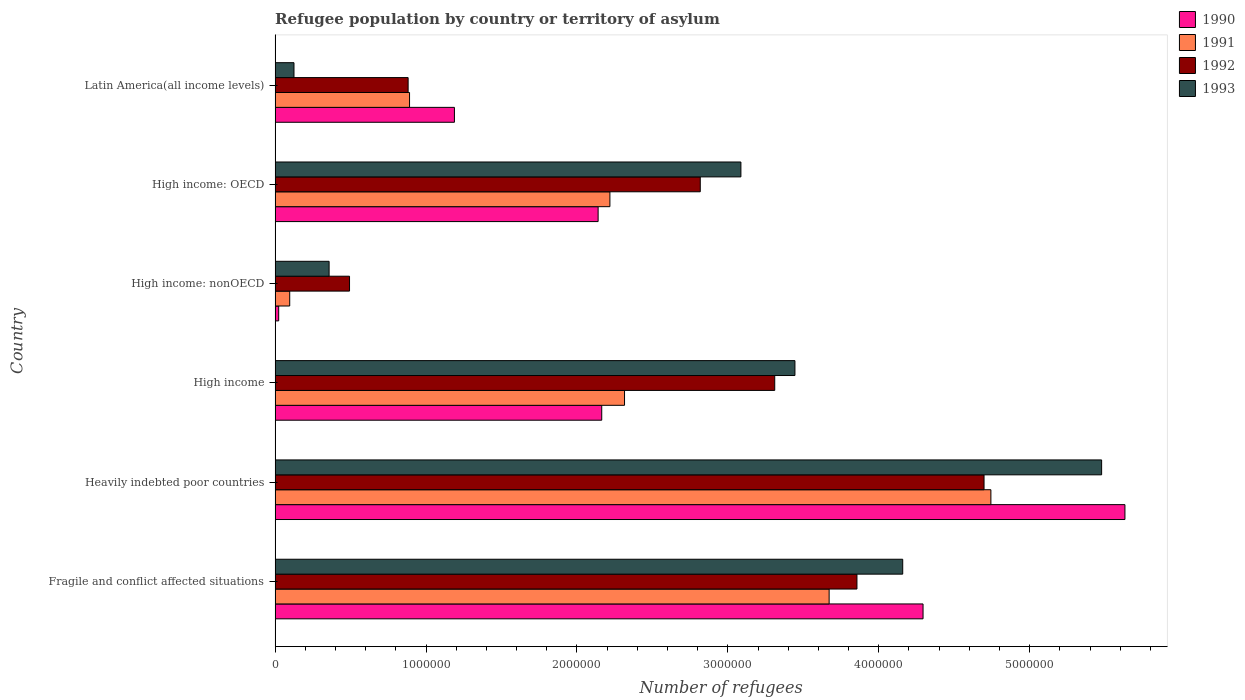How many groups of bars are there?
Provide a short and direct response. 6. Are the number of bars on each tick of the Y-axis equal?
Offer a terse response. Yes. How many bars are there on the 3rd tick from the top?
Your answer should be compact. 4. How many bars are there on the 2nd tick from the bottom?
Give a very brief answer. 4. What is the label of the 5th group of bars from the top?
Make the answer very short. Heavily indebted poor countries. In how many cases, is the number of bars for a given country not equal to the number of legend labels?
Provide a short and direct response. 0. What is the number of refugees in 1992 in High income?
Provide a succinct answer. 3.31e+06. Across all countries, what is the maximum number of refugees in 1993?
Keep it short and to the point. 5.48e+06. Across all countries, what is the minimum number of refugees in 1991?
Offer a very short reply. 9.69e+04. In which country was the number of refugees in 1993 maximum?
Provide a succinct answer. Heavily indebted poor countries. In which country was the number of refugees in 1990 minimum?
Your answer should be very brief. High income: nonOECD. What is the total number of refugees in 1993 in the graph?
Offer a very short reply. 1.66e+07. What is the difference between the number of refugees in 1992 in Heavily indebted poor countries and that in High income: OECD?
Keep it short and to the point. 1.88e+06. What is the difference between the number of refugees in 1990 in Heavily indebted poor countries and the number of refugees in 1991 in High income?
Offer a terse response. 3.32e+06. What is the average number of refugees in 1990 per country?
Give a very brief answer. 2.57e+06. What is the difference between the number of refugees in 1990 and number of refugees in 1991 in Heavily indebted poor countries?
Provide a succinct answer. 8.88e+05. What is the ratio of the number of refugees in 1993 in High income: OECD to that in Latin America(all income levels)?
Give a very brief answer. 24.64. Is the number of refugees in 1990 in High income: OECD less than that in Latin America(all income levels)?
Your response must be concise. No. What is the difference between the highest and the second highest number of refugees in 1991?
Ensure brevity in your answer.  1.07e+06. What is the difference between the highest and the lowest number of refugees in 1992?
Provide a succinct answer. 4.20e+06. Is it the case that in every country, the sum of the number of refugees in 1990 and number of refugees in 1993 is greater than the sum of number of refugees in 1991 and number of refugees in 1992?
Ensure brevity in your answer.  No. What does the 4th bar from the top in High income: nonOECD represents?
Ensure brevity in your answer.  1990. Are all the bars in the graph horizontal?
Make the answer very short. Yes. How many countries are there in the graph?
Provide a succinct answer. 6. What is the difference between two consecutive major ticks on the X-axis?
Make the answer very short. 1.00e+06. Are the values on the major ticks of X-axis written in scientific E-notation?
Ensure brevity in your answer.  No. Does the graph contain any zero values?
Ensure brevity in your answer.  No. Does the graph contain grids?
Your answer should be compact. No. How many legend labels are there?
Provide a succinct answer. 4. How are the legend labels stacked?
Offer a terse response. Vertical. What is the title of the graph?
Provide a short and direct response. Refugee population by country or territory of asylum. What is the label or title of the X-axis?
Ensure brevity in your answer.  Number of refugees. What is the Number of refugees in 1990 in Fragile and conflict affected situations?
Offer a very short reply. 4.29e+06. What is the Number of refugees in 1991 in Fragile and conflict affected situations?
Ensure brevity in your answer.  3.67e+06. What is the Number of refugees in 1992 in Fragile and conflict affected situations?
Provide a succinct answer. 3.86e+06. What is the Number of refugees of 1993 in Fragile and conflict affected situations?
Provide a succinct answer. 4.16e+06. What is the Number of refugees in 1990 in Heavily indebted poor countries?
Make the answer very short. 5.63e+06. What is the Number of refugees in 1991 in Heavily indebted poor countries?
Ensure brevity in your answer.  4.74e+06. What is the Number of refugees of 1992 in Heavily indebted poor countries?
Your answer should be very brief. 4.70e+06. What is the Number of refugees of 1993 in Heavily indebted poor countries?
Keep it short and to the point. 5.48e+06. What is the Number of refugees of 1990 in High income?
Give a very brief answer. 2.16e+06. What is the Number of refugees in 1991 in High income?
Ensure brevity in your answer.  2.32e+06. What is the Number of refugees in 1992 in High income?
Your response must be concise. 3.31e+06. What is the Number of refugees of 1993 in High income?
Provide a short and direct response. 3.44e+06. What is the Number of refugees of 1990 in High income: nonOECD?
Make the answer very short. 2.39e+04. What is the Number of refugees in 1991 in High income: nonOECD?
Make the answer very short. 9.69e+04. What is the Number of refugees of 1992 in High income: nonOECD?
Your answer should be very brief. 4.93e+05. What is the Number of refugees in 1993 in High income: nonOECD?
Your response must be concise. 3.58e+05. What is the Number of refugees in 1990 in High income: OECD?
Your answer should be very brief. 2.14e+06. What is the Number of refugees in 1991 in High income: OECD?
Keep it short and to the point. 2.22e+06. What is the Number of refugees of 1992 in High income: OECD?
Your answer should be very brief. 2.82e+06. What is the Number of refugees in 1993 in High income: OECD?
Offer a very short reply. 3.09e+06. What is the Number of refugees in 1990 in Latin America(all income levels)?
Offer a terse response. 1.19e+06. What is the Number of refugees of 1991 in Latin America(all income levels)?
Offer a terse response. 8.91e+05. What is the Number of refugees in 1992 in Latin America(all income levels)?
Provide a short and direct response. 8.82e+05. What is the Number of refugees of 1993 in Latin America(all income levels)?
Make the answer very short. 1.25e+05. Across all countries, what is the maximum Number of refugees in 1990?
Provide a short and direct response. 5.63e+06. Across all countries, what is the maximum Number of refugees in 1991?
Ensure brevity in your answer.  4.74e+06. Across all countries, what is the maximum Number of refugees in 1992?
Give a very brief answer. 4.70e+06. Across all countries, what is the maximum Number of refugees of 1993?
Keep it short and to the point. 5.48e+06. Across all countries, what is the minimum Number of refugees of 1990?
Offer a terse response. 2.39e+04. Across all countries, what is the minimum Number of refugees in 1991?
Make the answer very short. 9.69e+04. Across all countries, what is the minimum Number of refugees of 1992?
Keep it short and to the point. 4.93e+05. Across all countries, what is the minimum Number of refugees in 1993?
Keep it short and to the point. 1.25e+05. What is the total Number of refugees in 1990 in the graph?
Ensure brevity in your answer.  1.54e+07. What is the total Number of refugees in 1991 in the graph?
Ensure brevity in your answer.  1.39e+07. What is the total Number of refugees in 1992 in the graph?
Offer a very short reply. 1.61e+07. What is the total Number of refugees of 1993 in the graph?
Your answer should be compact. 1.66e+07. What is the difference between the Number of refugees in 1990 in Fragile and conflict affected situations and that in Heavily indebted poor countries?
Provide a succinct answer. -1.34e+06. What is the difference between the Number of refugees of 1991 in Fragile and conflict affected situations and that in Heavily indebted poor countries?
Keep it short and to the point. -1.07e+06. What is the difference between the Number of refugees in 1992 in Fragile and conflict affected situations and that in Heavily indebted poor countries?
Ensure brevity in your answer.  -8.42e+05. What is the difference between the Number of refugees in 1993 in Fragile and conflict affected situations and that in Heavily indebted poor countries?
Give a very brief answer. -1.32e+06. What is the difference between the Number of refugees in 1990 in Fragile and conflict affected situations and that in High income?
Provide a succinct answer. 2.13e+06. What is the difference between the Number of refugees of 1991 in Fragile and conflict affected situations and that in High income?
Your answer should be very brief. 1.36e+06. What is the difference between the Number of refugees in 1992 in Fragile and conflict affected situations and that in High income?
Provide a short and direct response. 5.45e+05. What is the difference between the Number of refugees of 1993 in Fragile and conflict affected situations and that in High income?
Offer a very short reply. 7.14e+05. What is the difference between the Number of refugees of 1990 in Fragile and conflict affected situations and that in High income: nonOECD?
Provide a short and direct response. 4.27e+06. What is the difference between the Number of refugees of 1991 in Fragile and conflict affected situations and that in High income: nonOECD?
Provide a short and direct response. 3.57e+06. What is the difference between the Number of refugees in 1992 in Fragile and conflict affected situations and that in High income: nonOECD?
Ensure brevity in your answer.  3.36e+06. What is the difference between the Number of refugees in 1993 in Fragile and conflict affected situations and that in High income: nonOECD?
Keep it short and to the point. 3.80e+06. What is the difference between the Number of refugees in 1990 in Fragile and conflict affected situations and that in High income: OECD?
Your answer should be compact. 2.15e+06. What is the difference between the Number of refugees in 1991 in Fragile and conflict affected situations and that in High income: OECD?
Your answer should be compact. 1.45e+06. What is the difference between the Number of refugees in 1992 in Fragile and conflict affected situations and that in High income: OECD?
Your answer should be compact. 1.04e+06. What is the difference between the Number of refugees in 1993 in Fragile and conflict affected situations and that in High income: OECD?
Ensure brevity in your answer.  1.07e+06. What is the difference between the Number of refugees in 1990 in Fragile and conflict affected situations and that in Latin America(all income levels)?
Keep it short and to the point. 3.10e+06. What is the difference between the Number of refugees of 1991 in Fragile and conflict affected situations and that in Latin America(all income levels)?
Offer a very short reply. 2.78e+06. What is the difference between the Number of refugees in 1992 in Fragile and conflict affected situations and that in Latin America(all income levels)?
Provide a succinct answer. 2.97e+06. What is the difference between the Number of refugees in 1993 in Fragile and conflict affected situations and that in Latin America(all income levels)?
Ensure brevity in your answer.  4.03e+06. What is the difference between the Number of refugees in 1990 in Heavily indebted poor countries and that in High income?
Ensure brevity in your answer.  3.47e+06. What is the difference between the Number of refugees of 1991 in Heavily indebted poor countries and that in High income?
Offer a terse response. 2.43e+06. What is the difference between the Number of refugees of 1992 in Heavily indebted poor countries and that in High income?
Offer a very short reply. 1.39e+06. What is the difference between the Number of refugees in 1993 in Heavily indebted poor countries and that in High income?
Your answer should be very brief. 2.03e+06. What is the difference between the Number of refugees in 1990 in Heavily indebted poor countries and that in High income: nonOECD?
Make the answer very short. 5.61e+06. What is the difference between the Number of refugees of 1991 in Heavily indebted poor countries and that in High income: nonOECD?
Your answer should be very brief. 4.65e+06. What is the difference between the Number of refugees of 1992 in Heavily indebted poor countries and that in High income: nonOECD?
Make the answer very short. 4.20e+06. What is the difference between the Number of refugees of 1993 in Heavily indebted poor countries and that in High income: nonOECD?
Offer a terse response. 5.12e+06. What is the difference between the Number of refugees of 1990 in Heavily indebted poor countries and that in High income: OECD?
Make the answer very short. 3.49e+06. What is the difference between the Number of refugees in 1991 in Heavily indebted poor countries and that in High income: OECD?
Your response must be concise. 2.52e+06. What is the difference between the Number of refugees of 1992 in Heavily indebted poor countries and that in High income: OECD?
Offer a terse response. 1.88e+06. What is the difference between the Number of refugees in 1993 in Heavily indebted poor countries and that in High income: OECD?
Offer a very short reply. 2.39e+06. What is the difference between the Number of refugees of 1990 in Heavily indebted poor countries and that in Latin America(all income levels)?
Make the answer very short. 4.44e+06. What is the difference between the Number of refugees of 1991 in Heavily indebted poor countries and that in Latin America(all income levels)?
Provide a short and direct response. 3.85e+06. What is the difference between the Number of refugees of 1992 in Heavily indebted poor countries and that in Latin America(all income levels)?
Make the answer very short. 3.82e+06. What is the difference between the Number of refugees of 1993 in Heavily indebted poor countries and that in Latin America(all income levels)?
Your response must be concise. 5.35e+06. What is the difference between the Number of refugees of 1990 in High income and that in High income: nonOECD?
Ensure brevity in your answer.  2.14e+06. What is the difference between the Number of refugees in 1991 in High income and that in High income: nonOECD?
Keep it short and to the point. 2.22e+06. What is the difference between the Number of refugees of 1992 in High income and that in High income: nonOECD?
Offer a very short reply. 2.82e+06. What is the difference between the Number of refugees of 1993 in High income and that in High income: nonOECD?
Your answer should be very brief. 3.09e+06. What is the difference between the Number of refugees in 1990 in High income and that in High income: OECD?
Make the answer very short. 2.39e+04. What is the difference between the Number of refugees of 1991 in High income and that in High income: OECD?
Ensure brevity in your answer.  9.69e+04. What is the difference between the Number of refugees of 1992 in High income and that in High income: OECD?
Your answer should be very brief. 4.93e+05. What is the difference between the Number of refugees in 1993 in High income and that in High income: OECD?
Keep it short and to the point. 3.58e+05. What is the difference between the Number of refugees of 1990 in High income and that in Latin America(all income levels)?
Offer a very short reply. 9.76e+05. What is the difference between the Number of refugees of 1991 in High income and that in Latin America(all income levels)?
Your answer should be very brief. 1.42e+06. What is the difference between the Number of refugees of 1992 in High income and that in Latin America(all income levels)?
Provide a succinct answer. 2.43e+06. What is the difference between the Number of refugees of 1993 in High income and that in Latin America(all income levels)?
Keep it short and to the point. 3.32e+06. What is the difference between the Number of refugees in 1990 in High income: nonOECD and that in High income: OECD?
Offer a very short reply. -2.12e+06. What is the difference between the Number of refugees of 1991 in High income: nonOECD and that in High income: OECD?
Offer a terse response. -2.12e+06. What is the difference between the Number of refugees in 1992 in High income: nonOECD and that in High income: OECD?
Make the answer very short. -2.32e+06. What is the difference between the Number of refugees in 1993 in High income: nonOECD and that in High income: OECD?
Offer a terse response. -2.73e+06. What is the difference between the Number of refugees in 1990 in High income: nonOECD and that in Latin America(all income levels)?
Offer a terse response. -1.16e+06. What is the difference between the Number of refugees in 1991 in High income: nonOECD and that in Latin America(all income levels)?
Provide a short and direct response. -7.94e+05. What is the difference between the Number of refugees in 1992 in High income: nonOECD and that in Latin America(all income levels)?
Provide a succinct answer. -3.88e+05. What is the difference between the Number of refugees of 1993 in High income: nonOECD and that in Latin America(all income levels)?
Your response must be concise. 2.33e+05. What is the difference between the Number of refugees of 1990 in High income: OECD and that in Latin America(all income levels)?
Your answer should be compact. 9.52e+05. What is the difference between the Number of refugees of 1991 in High income: OECD and that in Latin America(all income levels)?
Your answer should be compact. 1.33e+06. What is the difference between the Number of refugees of 1992 in High income: OECD and that in Latin America(all income levels)?
Offer a very short reply. 1.94e+06. What is the difference between the Number of refugees in 1993 in High income: OECD and that in Latin America(all income levels)?
Your response must be concise. 2.96e+06. What is the difference between the Number of refugees of 1990 in Fragile and conflict affected situations and the Number of refugees of 1991 in Heavily indebted poor countries?
Provide a succinct answer. -4.49e+05. What is the difference between the Number of refugees of 1990 in Fragile and conflict affected situations and the Number of refugees of 1992 in Heavily indebted poor countries?
Your answer should be compact. -4.04e+05. What is the difference between the Number of refugees in 1990 in Fragile and conflict affected situations and the Number of refugees in 1993 in Heavily indebted poor countries?
Make the answer very short. -1.18e+06. What is the difference between the Number of refugees in 1991 in Fragile and conflict affected situations and the Number of refugees in 1992 in Heavily indebted poor countries?
Your response must be concise. -1.03e+06. What is the difference between the Number of refugees in 1991 in Fragile and conflict affected situations and the Number of refugees in 1993 in Heavily indebted poor countries?
Your answer should be very brief. -1.81e+06. What is the difference between the Number of refugees in 1992 in Fragile and conflict affected situations and the Number of refugees in 1993 in Heavily indebted poor countries?
Keep it short and to the point. -1.62e+06. What is the difference between the Number of refugees of 1990 in Fragile and conflict affected situations and the Number of refugees of 1991 in High income?
Offer a terse response. 1.98e+06. What is the difference between the Number of refugees in 1990 in Fragile and conflict affected situations and the Number of refugees in 1992 in High income?
Provide a short and direct response. 9.83e+05. What is the difference between the Number of refugees of 1990 in Fragile and conflict affected situations and the Number of refugees of 1993 in High income?
Provide a succinct answer. 8.49e+05. What is the difference between the Number of refugees of 1991 in Fragile and conflict affected situations and the Number of refugees of 1992 in High income?
Provide a short and direct response. 3.60e+05. What is the difference between the Number of refugees of 1991 in Fragile and conflict affected situations and the Number of refugees of 1993 in High income?
Provide a succinct answer. 2.27e+05. What is the difference between the Number of refugees in 1992 in Fragile and conflict affected situations and the Number of refugees in 1993 in High income?
Your response must be concise. 4.11e+05. What is the difference between the Number of refugees in 1990 in Fragile and conflict affected situations and the Number of refugees in 1991 in High income: nonOECD?
Provide a succinct answer. 4.20e+06. What is the difference between the Number of refugees in 1990 in Fragile and conflict affected situations and the Number of refugees in 1992 in High income: nonOECD?
Your answer should be very brief. 3.80e+06. What is the difference between the Number of refugees in 1990 in Fragile and conflict affected situations and the Number of refugees in 1993 in High income: nonOECD?
Ensure brevity in your answer.  3.94e+06. What is the difference between the Number of refugees of 1991 in Fragile and conflict affected situations and the Number of refugees of 1992 in High income: nonOECD?
Your response must be concise. 3.18e+06. What is the difference between the Number of refugees of 1991 in Fragile and conflict affected situations and the Number of refugees of 1993 in High income: nonOECD?
Provide a succinct answer. 3.31e+06. What is the difference between the Number of refugees of 1992 in Fragile and conflict affected situations and the Number of refugees of 1993 in High income: nonOECD?
Your response must be concise. 3.50e+06. What is the difference between the Number of refugees in 1990 in Fragile and conflict affected situations and the Number of refugees in 1991 in High income: OECD?
Your response must be concise. 2.07e+06. What is the difference between the Number of refugees of 1990 in Fragile and conflict affected situations and the Number of refugees of 1992 in High income: OECD?
Offer a very short reply. 1.48e+06. What is the difference between the Number of refugees of 1990 in Fragile and conflict affected situations and the Number of refugees of 1993 in High income: OECD?
Provide a succinct answer. 1.21e+06. What is the difference between the Number of refugees in 1991 in Fragile and conflict affected situations and the Number of refugees in 1992 in High income: OECD?
Your response must be concise. 8.54e+05. What is the difference between the Number of refugees of 1991 in Fragile and conflict affected situations and the Number of refugees of 1993 in High income: OECD?
Provide a succinct answer. 5.85e+05. What is the difference between the Number of refugees in 1992 in Fragile and conflict affected situations and the Number of refugees in 1993 in High income: OECD?
Your answer should be compact. 7.69e+05. What is the difference between the Number of refugees in 1990 in Fragile and conflict affected situations and the Number of refugees in 1991 in Latin America(all income levels)?
Offer a very short reply. 3.40e+06. What is the difference between the Number of refugees in 1990 in Fragile and conflict affected situations and the Number of refugees in 1992 in Latin America(all income levels)?
Make the answer very short. 3.41e+06. What is the difference between the Number of refugees of 1990 in Fragile and conflict affected situations and the Number of refugees of 1993 in Latin America(all income levels)?
Offer a terse response. 4.17e+06. What is the difference between the Number of refugees of 1991 in Fragile and conflict affected situations and the Number of refugees of 1992 in Latin America(all income levels)?
Give a very brief answer. 2.79e+06. What is the difference between the Number of refugees in 1991 in Fragile and conflict affected situations and the Number of refugees in 1993 in Latin America(all income levels)?
Offer a terse response. 3.55e+06. What is the difference between the Number of refugees of 1992 in Fragile and conflict affected situations and the Number of refugees of 1993 in Latin America(all income levels)?
Your response must be concise. 3.73e+06. What is the difference between the Number of refugees in 1990 in Heavily indebted poor countries and the Number of refugees in 1991 in High income?
Make the answer very short. 3.32e+06. What is the difference between the Number of refugees in 1990 in Heavily indebted poor countries and the Number of refugees in 1992 in High income?
Ensure brevity in your answer.  2.32e+06. What is the difference between the Number of refugees in 1990 in Heavily indebted poor countries and the Number of refugees in 1993 in High income?
Offer a very short reply. 2.19e+06. What is the difference between the Number of refugees of 1991 in Heavily indebted poor countries and the Number of refugees of 1992 in High income?
Ensure brevity in your answer.  1.43e+06. What is the difference between the Number of refugees of 1991 in Heavily indebted poor countries and the Number of refugees of 1993 in High income?
Ensure brevity in your answer.  1.30e+06. What is the difference between the Number of refugees of 1992 in Heavily indebted poor countries and the Number of refugees of 1993 in High income?
Ensure brevity in your answer.  1.25e+06. What is the difference between the Number of refugees of 1990 in Heavily indebted poor countries and the Number of refugees of 1991 in High income: nonOECD?
Keep it short and to the point. 5.53e+06. What is the difference between the Number of refugees in 1990 in Heavily indebted poor countries and the Number of refugees in 1992 in High income: nonOECD?
Provide a succinct answer. 5.14e+06. What is the difference between the Number of refugees of 1990 in Heavily indebted poor countries and the Number of refugees of 1993 in High income: nonOECD?
Keep it short and to the point. 5.27e+06. What is the difference between the Number of refugees in 1991 in Heavily indebted poor countries and the Number of refugees in 1992 in High income: nonOECD?
Offer a very short reply. 4.25e+06. What is the difference between the Number of refugees of 1991 in Heavily indebted poor countries and the Number of refugees of 1993 in High income: nonOECD?
Your response must be concise. 4.38e+06. What is the difference between the Number of refugees in 1992 in Heavily indebted poor countries and the Number of refugees in 1993 in High income: nonOECD?
Offer a very short reply. 4.34e+06. What is the difference between the Number of refugees in 1990 in Heavily indebted poor countries and the Number of refugees in 1991 in High income: OECD?
Provide a short and direct response. 3.41e+06. What is the difference between the Number of refugees in 1990 in Heavily indebted poor countries and the Number of refugees in 1992 in High income: OECD?
Provide a short and direct response. 2.81e+06. What is the difference between the Number of refugees of 1990 in Heavily indebted poor countries and the Number of refugees of 1993 in High income: OECD?
Make the answer very short. 2.54e+06. What is the difference between the Number of refugees in 1991 in Heavily indebted poor countries and the Number of refugees in 1992 in High income: OECD?
Make the answer very short. 1.93e+06. What is the difference between the Number of refugees in 1991 in Heavily indebted poor countries and the Number of refugees in 1993 in High income: OECD?
Ensure brevity in your answer.  1.66e+06. What is the difference between the Number of refugees in 1992 in Heavily indebted poor countries and the Number of refugees in 1993 in High income: OECD?
Offer a terse response. 1.61e+06. What is the difference between the Number of refugees in 1990 in Heavily indebted poor countries and the Number of refugees in 1991 in Latin America(all income levels)?
Offer a very short reply. 4.74e+06. What is the difference between the Number of refugees of 1990 in Heavily indebted poor countries and the Number of refugees of 1992 in Latin America(all income levels)?
Ensure brevity in your answer.  4.75e+06. What is the difference between the Number of refugees of 1990 in Heavily indebted poor countries and the Number of refugees of 1993 in Latin America(all income levels)?
Make the answer very short. 5.51e+06. What is the difference between the Number of refugees in 1991 in Heavily indebted poor countries and the Number of refugees in 1992 in Latin America(all income levels)?
Your answer should be compact. 3.86e+06. What is the difference between the Number of refugees in 1991 in Heavily indebted poor countries and the Number of refugees in 1993 in Latin America(all income levels)?
Your answer should be very brief. 4.62e+06. What is the difference between the Number of refugees of 1992 in Heavily indebted poor countries and the Number of refugees of 1993 in Latin America(all income levels)?
Keep it short and to the point. 4.57e+06. What is the difference between the Number of refugees in 1990 in High income and the Number of refugees in 1991 in High income: nonOECD?
Ensure brevity in your answer.  2.07e+06. What is the difference between the Number of refugees of 1990 in High income and the Number of refugees of 1992 in High income: nonOECD?
Your response must be concise. 1.67e+06. What is the difference between the Number of refugees of 1990 in High income and the Number of refugees of 1993 in High income: nonOECD?
Provide a succinct answer. 1.81e+06. What is the difference between the Number of refugees of 1991 in High income and the Number of refugees of 1992 in High income: nonOECD?
Provide a succinct answer. 1.82e+06. What is the difference between the Number of refugees of 1991 in High income and the Number of refugees of 1993 in High income: nonOECD?
Your answer should be very brief. 1.96e+06. What is the difference between the Number of refugees of 1992 in High income and the Number of refugees of 1993 in High income: nonOECD?
Make the answer very short. 2.95e+06. What is the difference between the Number of refugees of 1990 in High income and the Number of refugees of 1991 in High income: OECD?
Provide a short and direct response. -5.41e+04. What is the difference between the Number of refugees in 1990 in High income and the Number of refugees in 1992 in High income: OECD?
Offer a terse response. -6.53e+05. What is the difference between the Number of refugees of 1990 in High income and the Number of refugees of 1993 in High income: OECD?
Your answer should be very brief. -9.22e+05. What is the difference between the Number of refugees of 1991 in High income and the Number of refugees of 1992 in High income: OECD?
Make the answer very short. -5.02e+05. What is the difference between the Number of refugees in 1991 in High income and the Number of refugees in 1993 in High income: OECD?
Offer a very short reply. -7.71e+05. What is the difference between the Number of refugees of 1992 in High income and the Number of refugees of 1993 in High income: OECD?
Provide a succinct answer. 2.24e+05. What is the difference between the Number of refugees of 1990 in High income and the Number of refugees of 1991 in Latin America(all income levels)?
Keep it short and to the point. 1.27e+06. What is the difference between the Number of refugees of 1990 in High income and the Number of refugees of 1992 in Latin America(all income levels)?
Keep it short and to the point. 1.28e+06. What is the difference between the Number of refugees in 1990 in High income and the Number of refugees in 1993 in Latin America(all income levels)?
Make the answer very short. 2.04e+06. What is the difference between the Number of refugees in 1991 in High income and the Number of refugees in 1992 in Latin America(all income levels)?
Provide a short and direct response. 1.43e+06. What is the difference between the Number of refugees in 1991 in High income and the Number of refugees in 1993 in Latin America(all income levels)?
Keep it short and to the point. 2.19e+06. What is the difference between the Number of refugees in 1992 in High income and the Number of refugees in 1993 in Latin America(all income levels)?
Provide a short and direct response. 3.19e+06. What is the difference between the Number of refugees of 1990 in High income: nonOECD and the Number of refugees of 1991 in High income: OECD?
Offer a terse response. -2.19e+06. What is the difference between the Number of refugees of 1990 in High income: nonOECD and the Number of refugees of 1992 in High income: OECD?
Ensure brevity in your answer.  -2.79e+06. What is the difference between the Number of refugees of 1990 in High income: nonOECD and the Number of refugees of 1993 in High income: OECD?
Offer a very short reply. -3.06e+06. What is the difference between the Number of refugees of 1991 in High income: nonOECD and the Number of refugees of 1992 in High income: OECD?
Ensure brevity in your answer.  -2.72e+06. What is the difference between the Number of refugees in 1991 in High income: nonOECD and the Number of refugees in 1993 in High income: OECD?
Provide a succinct answer. -2.99e+06. What is the difference between the Number of refugees in 1992 in High income: nonOECD and the Number of refugees in 1993 in High income: OECD?
Give a very brief answer. -2.59e+06. What is the difference between the Number of refugees of 1990 in High income: nonOECD and the Number of refugees of 1991 in Latin America(all income levels)?
Your answer should be compact. -8.67e+05. What is the difference between the Number of refugees of 1990 in High income: nonOECD and the Number of refugees of 1992 in Latin America(all income levels)?
Offer a terse response. -8.58e+05. What is the difference between the Number of refugees in 1990 in High income: nonOECD and the Number of refugees in 1993 in Latin America(all income levels)?
Provide a succinct answer. -1.01e+05. What is the difference between the Number of refugees in 1991 in High income: nonOECD and the Number of refugees in 1992 in Latin America(all income levels)?
Your answer should be very brief. -7.85e+05. What is the difference between the Number of refugees of 1991 in High income: nonOECD and the Number of refugees of 1993 in Latin America(all income levels)?
Provide a succinct answer. -2.83e+04. What is the difference between the Number of refugees in 1992 in High income: nonOECD and the Number of refugees in 1993 in Latin America(all income levels)?
Your answer should be very brief. 3.68e+05. What is the difference between the Number of refugees in 1990 in High income: OECD and the Number of refugees in 1991 in Latin America(all income levels)?
Offer a very short reply. 1.25e+06. What is the difference between the Number of refugees of 1990 in High income: OECD and the Number of refugees of 1992 in Latin America(all income levels)?
Make the answer very short. 1.26e+06. What is the difference between the Number of refugees in 1990 in High income: OECD and the Number of refugees in 1993 in Latin America(all income levels)?
Your answer should be compact. 2.02e+06. What is the difference between the Number of refugees of 1991 in High income: OECD and the Number of refugees of 1992 in Latin America(all income levels)?
Give a very brief answer. 1.34e+06. What is the difference between the Number of refugees of 1991 in High income: OECD and the Number of refugees of 1993 in Latin America(all income levels)?
Your answer should be compact. 2.09e+06. What is the difference between the Number of refugees of 1992 in High income: OECD and the Number of refugees of 1993 in Latin America(all income levels)?
Ensure brevity in your answer.  2.69e+06. What is the average Number of refugees of 1990 per country?
Provide a succinct answer. 2.57e+06. What is the average Number of refugees of 1991 per country?
Keep it short and to the point. 2.32e+06. What is the average Number of refugees in 1992 per country?
Keep it short and to the point. 2.68e+06. What is the average Number of refugees in 1993 per country?
Give a very brief answer. 2.77e+06. What is the difference between the Number of refugees in 1990 and Number of refugees in 1991 in Fragile and conflict affected situations?
Offer a very short reply. 6.22e+05. What is the difference between the Number of refugees of 1990 and Number of refugees of 1992 in Fragile and conflict affected situations?
Offer a very short reply. 4.38e+05. What is the difference between the Number of refugees in 1990 and Number of refugees in 1993 in Fragile and conflict affected situations?
Give a very brief answer. 1.35e+05. What is the difference between the Number of refugees in 1991 and Number of refugees in 1992 in Fragile and conflict affected situations?
Your answer should be very brief. -1.84e+05. What is the difference between the Number of refugees of 1991 and Number of refugees of 1993 in Fragile and conflict affected situations?
Your answer should be very brief. -4.88e+05. What is the difference between the Number of refugees in 1992 and Number of refugees in 1993 in Fragile and conflict affected situations?
Provide a short and direct response. -3.03e+05. What is the difference between the Number of refugees in 1990 and Number of refugees in 1991 in Heavily indebted poor countries?
Provide a succinct answer. 8.88e+05. What is the difference between the Number of refugees in 1990 and Number of refugees in 1992 in Heavily indebted poor countries?
Offer a very short reply. 9.34e+05. What is the difference between the Number of refugees in 1990 and Number of refugees in 1993 in Heavily indebted poor countries?
Provide a short and direct response. 1.54e+05. What is the difference between the Number of refugees of 1991 and Number of refugees of 1992 in Heavily indebted poor countries?
Your response must be concise. 4.54e+04. What is the difference between the Number of refugees of 1991 and Number of refugees of 1993 in Heavily indebted poor countries?
Your answer should be very brief. -7.34e+05. What is the difference between the Number of refugees in 1992 and Number of refugees in 1993 in Heavily indebted poor countries?
Provide a succinct answer. -7.79e+05. What is the difference between the Number of refugees in 1990 and Number of refugees in 1991 in High income?
Provide a succinct answer. -1.51e+05. What is the difference between the Number of refugees of 1990 and Number of refugees of 1992 in High income?
Your response must be concise. -1.15e+06. What is the difference between the Number of refugees in 1990 and Number of refugees in 1993 in High income?
Offer a terse response. -1.28e+06. What is the difference between the Number of refugees of 1991 and Number of refugees of 1992 in High income?
Your response must be concise. -9.95e+05. What is the difference between the Number of refugees of 1991 and Number of refugees of 1993 in High income?
Your response must be concise. -1.13e+06. What is the difference between the Number of refugees of 1992 and Number of refugees of 1993 in High income?
Make the answer very short. -1.34e+05. What is the difference between the Number of refugees in 1990 and Number of refugees in 1991 in High income: nonOECD?
Your response must be concise. -7.30e+04. What is the difference between the Number of refugees of 1990 and Number of refugees of 1992 in High income: nonOECD?
Provide a short and direct response. -4.69e+05. What is the difference between the Number of refugees of 1990 and Number of refugees of 1993 in High income: nonOECD?
Make the answer very short. -3.34e+05. What is the difference between the Number of refugees of 1991 and Number of refugees of 1992 in High income: nonOECD?
Provide a succinct answer. -3.96e+05. What is the difference between the Number of refugees of 1991 and Number of refugees of 1993 in High income: nonOECD?
Ensure brevity in your answer.  -2.61e+05. What is the difference between the Number of refugees in 1992 and Number of refugees in 1993 in High income: nonOECD?
Ensure brevity in your answer.  1.35e+05. What is the difference between the Number of refugees of 1990 and Number of refugees of 1991 in High income: OECD?
Give a very brief answer. -7.80e+04. What is the difference between the Number of refugees of 1990 and Number of refugees of 1992 in High income: OECD?
Give a very brief answer. -6.77e+05. What is the difference between the Number of refugees in 1990 and Number of refugees in 1993 in High income: OECD?
Your response must be concise. -9.46e+05. What is the difference between the Number of refugees of 1991 and Number of refugees of 1992 in High income: OECD?
Your response must be concise. -5.99e+05. What is the difference between the Number of refugees in 1991 and Number of refugees in 1993 in High income: OECD?
Your response must be concise. -8.68e+05. What is the difference between the Number of refugees in 1992 and Number of refugees in 1993 in High income: OECD?
Keep it short and to the point. -2.69e+05. What is the difference between the Number of refugees in 1990 and Number of refugees in 1991 in Latin America(all income levels)?
Your answer should be very brief. 2.97e+05. What is the difference between the Number of refugees of 1990 and Number of refugees of 1992 in Latin America(all income levels)?
Your answer should be compact. 3.07e+05. What is the difference between the Number of refugees of 1990 and Number of refugees of 1993 in Latin America(all income levels)?
Give a very brief answer. 1.06e+06. What is the difference between the Number of refugees in 1991 and Number of refugees in 1992 in Latin America(all income levels)?
Give a very brief answer. 9437. What is the difference between the Number of refugees in 1991 and Number of refugees in 1993 in Latin America(all income levels)?
Offer a very short reply. 7.66e+05. What is the difference between the Number of refugees of 1992 and Number of refugees of 1993 in Latin America(all income levels)?
Provide a short and direct response. 7.56e+05. What is the ratio of the Number of refugees in 1990 in Fragile and conflict affected situations to that in Heavily indebted poor countries?
Give a very brief answer. 0.76. What is the ratio of the Number of refugees of 1991 in Fragile and conflict affected situations to that in Heavily indebted poor countries?
Give a very brief answer. 0.77. What is the ratio of the Number of refugees of 1992 in Fragile and conflict affected situations to that in Heavily indebted poor countries?
Provide a succinct answer. 0.82. What is the ratio of the Number of refugees of 1993 in Fragile and conflict affected situations to that in Heavily indebted poor countries?
Your response must be concise. 0.76. What is the ratio of the Number of refugees of 1990 in Fragile and conflict affected situations to that in High income?
Make the answer very short. 1.98. What is the ratio of the Number of refugees in 1991 in Fragile and conflict affected situations to that in High income?
Ensure brevity in your answer.  1.59. What is the ratio of the Number of refugees of 1992 in Fragile and conflict affected situations to that in High income?
Your response must be concise. 1.16. What is the ratio of the Number of refugees in 1993 in Fragile and conflict affected situations to that in High income?
Keep it short and to the point. 1.21. What is the ratio of the Number of refugees of 1990 in Fragile and conflict affected situations to that in High income: nonOECD?
Offer a terse response. 179.65. What is the ratio of the Number of refugees of 1991 in Fragile and conflict affected situations to that in High income: nonOECD?
Your answer should be compact. 37.87. What is the ratio of the Number of refugees in 1992 in Fragile and conflict affected situations to that in High income: nonOECD?
Provide a succinct answer. 7.81. What is the ratio of the Number of refugees of 1993 in Fragile and conflict affected situations to that in High income: nonOECD?
Ensure brevity in your answer.  11.62. What is the ratio of the Number of refugees in 1990 in Fragile and conflict affected situations to that in High income: OECD?
Ensure brevity in your answer.  2.01. What is the ratio of the Number of refugees of 1991 in Fragile and conflict affected situations to that in High income: OECD?
Your answer should be very brief. 1.65. What is the ratio of the Number of refugees of 1992 in Fragile and conflict affected situations to that in High income: OECD?
Provide a succinct answer. 1.37. What is the ratio of the Number of refugees in 1993 in Fragile and conflict affected situations to that in High income: OECD?
Make the answer very short. 1.35. What is the ratio of the Number of refugees in 1990 in Fragile and conflict affected situations to that in Latin America(all income levels)?
Provide a short and direct response. 3.61. What is the ratio of the Number of refugees of 1991 in Fragile and conflict affected situations to that in Latin America(all income levels)?
Keep it short and to the point. 4.12. What is the ratio of the Number of refugees in 1992 in Fragile and conflict affected situations to that in Latin America(all income levels)?
Give a very brief answer. 4.37. What is the ratio of the Number of refugees of 1993 in Fragile and conflict affected situations to that in Latin America(all income levels)?
Your answer should be very brief. 33.19. What is the ratio of the Number of refugees of 1990 in Heavily indebted poor countries to that in High income?
Provide a succinct answer. 2.6. What is the ratio of the Number of refugees of 1991 in Heavily indebted poor countries to that in High income?
Your response must be concise. 2.05. What is the ratio of the Number of refugees of 1992 in Heavily indebted poor countries to that in High income?
Provide a short and direct response. 1.42. What is the ratio of the Number of refugees of 1993 in Heavily indebted poor countries to that in High income?
Make the answer very short. 1.59. What is the ratio of the Number of refugees of 1990 in Heavily indebted poor countries to that in High income: nonOECD?
Your answer should be very brief. 235.63. What is the ratio of the Number of refugees in 1991 in Heavily indebted poor countries to that in High income: nonOECD?
Offer a terse response. 48.93. What is the ratio of the Number of refugees in 1992 in Heavily indebted poor countries to that in High income: nonOECD?
Ensure brevity in your answer.  9.52. What is the ratio of the Number of refugees in 1993 in Heavily indebted poor countries to that in High income: nonOECD?
Ensure brevity in your answer.  15.3. What is the ratio of the Number of refugees of 1990 in Heavily indebted poor countries to that in High income: OECD?
Your answer should be very brief. 2.63. What is the ratio of the Number of refugees of 1991 in Heavily indebted poor countries to that in High income: OECD?
Offer a terse response. 2.14. What is the ratio of the Number of refugees of 1992 in Heavily indebted poor countries to that in High income: OECD?
Your response must be concise. 1.67. What is the ratio of the Number of refugees in 1993 in Heavily indebted poor countries to that in High income: OECD?
Offer a very short reply. 1.77. What is the ratio of the Number of refugees of 1990 in Heavily indebted poor countries to that in Latin America(all income levels)?
Your answer should be compact. 4.74. What is the ratio of the Number of refugees in 1991 in Heavily indebted poor countries to that in Latin America(all income levels)?
Your answer should be compact. 5.32. What is the ratio of the Number of refugees in 1992 in Heavily indebted poor countries to that in Latin America(all income levels)?
Give a very brief answer. 5.33. What is the ratio of the Number of refugees of 1993 in Heavily indebted poor countries to that in Latin America(all income levels)?
Give a very brief answer. 43.71. What is the ratio of the Number of refugees of 1990 in High income to that in High income: nonOECD?
Offer a terse response. 90.57. What is the ratio of the Number of refugees in 1991 in High income to that in High income: nonOECD?
Provide a short and direct response. 23.88. What is the ratio of the Number of refugees in 1992 in High income to that in High income: nonOECD?
Offer a very short reply. 6.71. What is the ratio of the Number of refugees in 1993 in High income to that in High income: nonOECD?
Offer a terse response. 9.62. What is the ratio of the Number of refugees of 1990 in High income to that in High income: OECD?
Offer a terse response. 1.01. What is the ratio of the Number of refugees of 1991 in High income to that in High income: OECD?
Give a very brief answer. 1.04. What is the ratio of the Number of refugees of 1992 in High income to that in High income: OECD?
Your response must be concise. 1.18. What is the ratio of the Number of refugees in 1993 in High income to that in High income: OECD?
Make the answer very short. 1.12. What is the ratio of the Number of refugees of 1990 in High income to that in Latin America(all income levels)?
Offer a very short reply. 1.82. What is the ratio of the Number of refugees of 1991 in High income to that in Latin America(all income levels)?
Offer a very short reply. 2.6. What is the ratio of the Number of refugees in 1992 in High income to that in Latin America(all income levels)?
Provide a succinct answer. 3.76. What is the ratio of the Number of refugees of 1993 in High income to that in Latin America(all income levels)?
Offer a terse response. 27.49. What is the ratio of the Number of refugees of 1990 in High income: nonOECD to that in High income: OECD?
Provide a short and direct response. 0.01. What is the ratio of the Number of refugees in 1991 in High income: nonOECD to that in High income: OECD?
Provide a short and direct response. 0.04. What is the ratio of the Number of refugees in 1992 in High income: nonOECD to that in High income: OECD?
Your response must be concise. 0.18. What is the ratio of the Number of refugees of 1993 in High income: nonOECD to that in High income: OECD?
Ensure brevity in your answer.  0.12. What is the ratio of the Number of refugees of 1990 in High income: nonOECD to that in Latin America(all income levels)?
Ensure brevity in your answer.  0.02. What is the ratio of the Number of refugees in 1991 in High income: nonOECD to that in Latin America(all income levels)?
Your response must be concise. 0.11. What is the ratio of the Number of refugees of 1992 in High income: nonOECD to that in Latin America(all income levels)?
Offer a very short reply. 0.56. What is the ratio of the Number of refugees in 1993 in High income: nonOECD to that in Latin America(all income levels)?
Provide a succinct answer. 2.86. What is the ratio of the Number of refugees in 1990 in High income: OECD to that in Latin America(all income levels)?
Provide a succinct answer. 1.8. What is the ratio of the Number of refugees of 1991 in High income: OECD to that in Latin America(all income levels)?
Keep it short and to the point. 2.49. What is the ratio of the Number of refugees in 1992 in High income: OECD to that in Latin America(all income levels)?
Your response must be concise. 3.2. What is the ratio of the Number of refugees in 1993 in High income: OECD to that in Latin America(all income levels)?
Give a very brief answer. 24.64. What is the difference between the highest and the second highest Number of refugees in 1990?
Offer a very short reply. 1.34e+06. What is the difference between the highest and the second highest Number of refugees in 1991?
Make the answer very short. 1.07e+06. What is the difference between the highest and the second highest Number of refugees of 1992?
Ensure brevity in your answer.  8.42e+05. What is the difference between the highest and the second highest Number of refugees of 1993?
Your answer should be very brief. 1.32e+06. What is the difference between the highest and the lowest Number of refugees of 1990?
Keep it short and to the point. 5.61e+06. What is the difference between the highest and the lowest Number of refugees of 1991?
Offer a terse response. 4.65e+06. What is the difference between the highest and the lowest Number of refugees in 1992?
Provide a short and direct response. 4.20e+06. What is the difference between the highest and the lowest Number of refugees of 1993?
Offer a very short reply. 5.35e+06. 